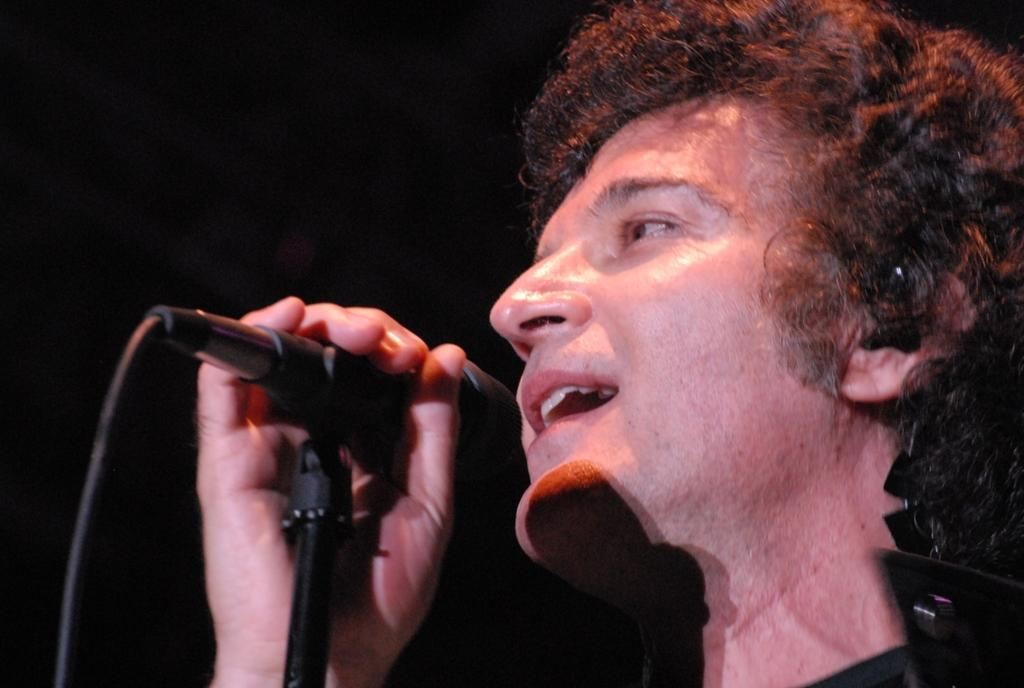Who is the main subject in the image? There is a man in the image. What is the man doing in the image? The man is singing. What object is the man holding in the image? The man is holding a microphone. What can be observed about the background of the image? The background of the image is dark. What religious beliefs does the man in the image follow? There is no information about the man's religious beliefs in the image. What flavor of ice cream is the man eating in the image? There is no ice cream present in the image. 